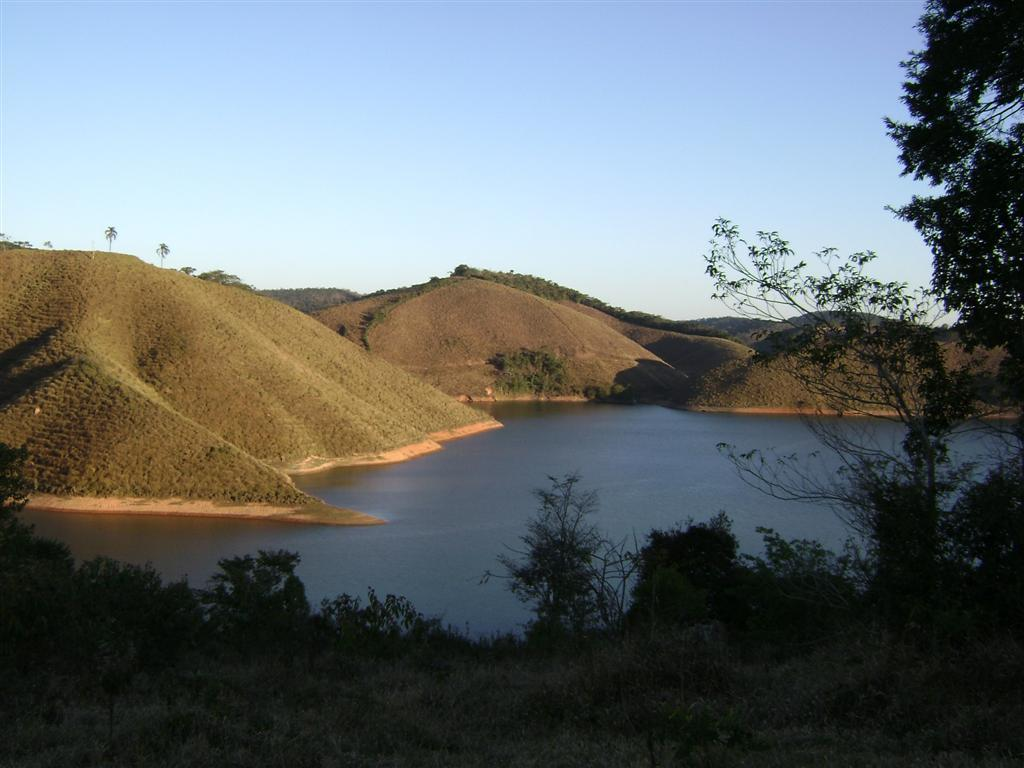What natural element is visible in the image? Water is visible in the image. What type of vegetation can be seen in the image? There are plants and trees in the image. What geographical feature is present in the image? There is a mountain in the image. What part of the natural environment is visible in the background of the image? The sky is visible in the background of the image. What type of toothpaste is being used by the achiever in the image? There is no achiever or toothpaste present in the image. What show is being performed by the plants in the image? There is no show being performed by the plants in the image; they are simply growing in their natural environment. 